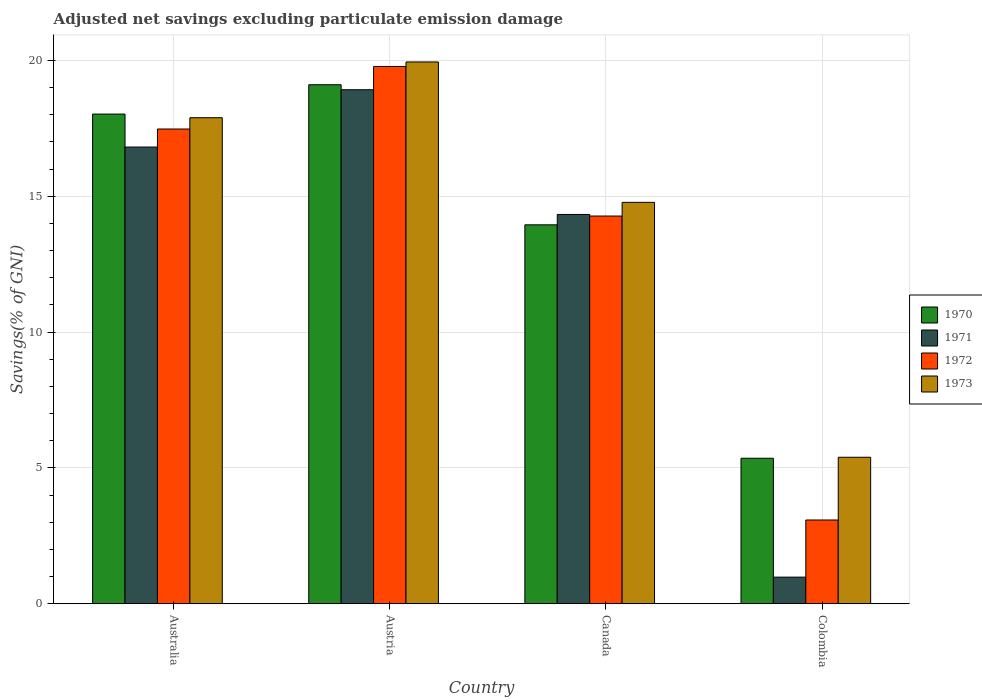How many different coloured bars are there?
Your response must be concise. 4. Are the number of bars on each tick of the X-axis equal?
Your answer should be very brief. Yes. How many bars are there on the 1st tick from the right?
Make the answer very short. 4. What is the label of the 3rd group of bars from the left?
Your answer should be very brief. Canada. What is the adjusted net savings in 1973 in Canada?
Offer a very short reply. 14.78. Across all countries, what is the maximum adjusted net savings in 1973?
Offer a very short reply. 19.94. Across all countries, what is the minimum adjusted net savings in 1971?
Offer a terse response. 0.98. In which country was the adjusted net savings in 1970 minimum?
Offer a terse response. Colombia. What is the total adjusted net savings in 1971 in the graph?
Make the answer very short. 51.04. What is the difference between the adjusted net savings in 1972 in Austria and that in Canada?
Your response must be concise. 5.51. What is the difference between the adjusted net savings in 1971 in Australia and the adjusted net savings in 1973 in Canada?
Your answer should be very brief. 2.04. What is the average adjusted net savings in 1972 per country?
Give a very brief answer. 13.65. What is the difference between the adjusted net savings of/in 1972 and adjusted net savings of/in 1971 in Colombia?
Make the answer very short. 2.1. In how many countries, is the adjusted net savings in 1972 greater than 3 %?
Give a very brief answer. 4. What is the ratio of the adjusted net savings in 1970 in Australia to that in Colombia?
Provide a short and direct response. 3.37. Is the adjusted net savings in 1971 in Austria less than that in Colombia?
Ensure brevity in your answer.  No. What is the difference between the highest and the second highest adjusted net savings in 1972?
Provide a short and direct response. -2.3. What is the difference between the highest and the lowest adjusted net savings in 1971?
Your response must be concise. 17.94. In how many countries, is the adjusted net savings in 1970 greater than the average adjusted net savings in 1970 taken over all countries?
Offer a terse response. 2. What does the 2nd bar from the right in Australia represents?
Make the answer very short. 1972. How many bars are there?
Ensure brevity in your answer.  16. Are all the bars in the graph horizontal?
Offer a very short reply. No. Does the graph contain any zero values?
Keep it short and to the point. No. Does the graph contain grids?
Offer a very short reply. Yes. What is the title of the graph?
Provide a succinct answer. Adjusted net savings excluding particulate emission damage. What is the label or title of the X-axis?
Offer a very short reply. Country. What is the label or title of the Y-axis?
Give a very brief answer. Savings(% of GNI). What is the Savings(% of GNI) of 1970 in Australia?
Offer a very short reply. 18.03. What is the Savings(% of GNI) of 1971 in Australia?
Your answer should be very brief. 16.81. What is the Savings(% of GNI) in 1972 in Australia?
Ensure brevity in your answer.  17.48. What is the Savings(% of GNI) in 1973 in Australia?
Keep it short and to the point. 17.89. What is the Savings(% of GNI) in 1970 in Austria?
Your response must be concise. 19.11. What is the Savings(% of GNI) of 1971 in Austria?
Give a very brief answer. 18.92. What is the Savings(% of GNI) of 1972 in Austria?
Your answer should be very brief. 19.78. What is the Savings(% of GNI) of 1973 in Austria?
Your answer should be compact. 19.94. What is the Savings(% of GNI) of 1970 in Canada?
Ensure brevity in your answer.  13.95. What is the Savings(% of GNI) in 1971 in Canada?
Offer a very short reply. 14.33. What is the Savings(% of GNI) in 1972 in Canada?
Your answer should be very brief. 14.27. What is the Savings(% of GNI) in 1973 in Canada?
Provide a succinct answer. 14.78. What is the Savings(% of GNI) in 1970 in Colombia?
Your response must be concise. 5.36. What is the Savings(% of GNI) of 1971 in Colombia?
Your answer should be compact. 0.98. What is the Savings(% of GNI) of 1972 in Colombia?
Your answer should be very brief. 3.08. What is the Savings(% of GNI) of 1973 in Colombia?
Keep it short and to the point. 5.39. Across all countries, what is the maximum Savings(% of GNI) of 1970?
Give a very brief answer. 19.11. Across all countries, what is the maximum Savings(% of GNI) in 1971?
Your response must be concise. 18.92. Across all countries, what is the maximum Savings(% of GNI) of 1972?
Ensure brevity in your answer.  19.78. Across all countries, what is the maximum Savings(% of GNI) in 1973?
Offer a very short reply. 19.94. Across all countries, what is the minimum Savings(% of GNI) in 1970?
Your response must be concise. 5.36. Across all countries, what is the minimum Savings(% of GNI) of 1971?
Provide a succinct answer. 0.98. Across all countries, what is the minimum Savings(% of GNI) in 1972?
Your answer should be compact. 3.08. Across all countries, what is the minimum Savings(% of GNI) in 1973?
Your answer should be very brief. 5.39. What is the total Savings(% of GNI) in 1970 in the graph?
Offer a terse response. 56.44. What is the total Savings(% of GNI) in 1971 in the graph?
Offer a very short reply. 51.04. What is the total Savings(% of GNI) in 1972 in the graph?
Offer a very short reply. 54.61. What is the total Savings(% of GNI) in 1973 in the graph?
Your answer should be very brief. 58.01. What is the difference between the Savings(% of GNI) of 1970 in Australia and that in Austria?
Ensure brevity in your answer.  -1.08. What is the difference between the Savings(% of GNI) in 1971 in Australia and that in Austria?
Your response must be concise. -2.11. What is the difference between the Savings(% of GNI) of 1972 in Australia and that in Austria?
Your response must be concise. -2.3. What is the difference between the Savings(% of GNI) of 1973 in Australia and that in Austria?
Provide a succinct answer. -2.05. What is the difference between the Savings(% of GNI) of 1970 in Australia and that in Canada?
Your response must be concise. 4.08. What is the difference between the Savings(% of GNI) of 1971 in Australia and that in Canada?
Keep it short and to the point. 2.48. What is the difference between the Savings(% of GNI) of 1972 in Australia and that in Canada?
Keep it short and to the point. 3.2. What is the difference between the Savings(% of GNI) of 1973 in Australia and that in Canada?
Keep it short and to the point. 3.12. What is the difference between the Savings(% of GNI) of 1970 in Australia and that in Colombia?
Your answer should be very brief. 12.67. What is the difference between the Savings(% of GNI) in 1971 in Australia and that in Colombia?
Make the answer very short. 15.83. What is the difference between the Savings(% of GNI) in 1972 in Australia and that in Colombia?
Keep it short and to the point. 14.39. What is the difference between the Savings(% of GNI) of 1970 in Austria and that in Canada?
Your response must be concise. 5.16. What is the difference between the Savings(% of GNI) in 1971 in Austria and that in Canada?
Provide a succinct answer. 4.59. What is the difference between the Savings(% of GNI) in 1972 in Austria and that in Canada?
Offer a very short reply. 5.51. What is the difference between the Savings(% of GNI) of 1973 in Austria and that in Canada?
Provide a short and direct response. 5.17. What is the difference between the Savings(% of GNI) of 1970 in Austria and that in Colombia?
Provide a short and direct response. 13.75. What is the difference between the Savings(% of GNI) in 1971 in Austria and that in Colombia?
Provide a succinct answer. 17.94. What is the difference between the Savings(% of GNI) in 1972 in Austria and that in Colombia?
Give a very brief answer. 16.7. What is the difference between the Savings(% of GNI) in 1973 in Austria and that in Colombia?
Provide a succinct answer. 14.55. What is the difference between the Savings(% of GNI) of 1970 in Canada and that in Colombia?
Your response must be concise. 8.59. What is the difference between the Savings(% of GNI) of 1971 in Canada and that in Colombia?
Ensure brevity in your answer.  13.35. What is the difference between the Savings(% of GNI) in 1972 in Canada and that in Colombia?
Offer a very short reply. 11.19. What is the difference between the Savings(% of GNI) in 1973 in Canada and that in Colombia?
Your answer should be compact. 9.38. What is the difference between the Savings(% of GNI) in 1970 in Australia and the Savings(% of GNI) in 1971 in Austria?
Your answer should be compact. -0.9. What is the difference between the Savings(% of GNI) in 1970 in Australia and the Savings(% of GNI) in 1972 in Austria?
Your answer should be very brief. -1.75. What is the difference between the Savings(% of GNI) of 1970 in Australia and the Savings(% of GNI) of 1973 in Austria?
Offer a terse response. -1.92. What is the difference between the Savings(% of GNI) in 1971 in Australia and the Savings(% of GNI) in 1972 in Austria?
Your response must be concise. -2.97. What is the difference between the Savings(% of GNI) of 1971 in Australia and the Savings(% of GNI) of 1973 in Austria?
Your answer should be very brief. -3.13. What is the difference between the Savings(% of GNI) in 1972 in Australia and the Savings(% of GNI) in 1973 in Austria?
Ensure brevity in your answer.  -2.47. What is the difference between the Savings(% of GNI) in 1970 in Australia and the Savings(% of GNI) in 1971 in Canada?
Your response must be concise. 3.7. What is the difference between the Savings(% of GNI) in 1970 in Australia and the Savings(% of GNI) in 1972 in Canada?
Keep it short and to the point. 3.75. What is the difference between the Savings(% of GNI) of 1970 in Australia and the Savings(% of GNI) of 1973 in Canada?
Offer a very short reply. 3.25. What is the difference between the Savings(% of GNI) of 1971 in Australia and the Savings(% of GNI) of 1972 in Canada?
Offer a terse response. 2.54. What is the difference between the Savings(% of GNI) of 1971 in Australia and the Savings(% of GNI) of 1973 in Canada?
Offer a terse response. 2.04. What is the difference between the Savings(% of GNI) in 1972 in Australia and the Savings(% of GNI) in 1973 in Canada?
Ensure brevity in your answer.  2.7. What is the difference between the Savings(% of GNI) in 1970 in Australia and the Savings(% of GNI) in 1971 in Colombia?
Make the answer very short. 17.05. What is the difference between the Savings(% of GNI) of 1970 in Australia and the Savings(% of GNI) of 1972 in Colombia?
Your answer should be very brief. 14.94. What is the difference between the Savings(% of GNI) in 1970 in Australia and the Savings(% of GNI) in 1973 in Colombia?
Give a very brief answer. 12.63. What is the difference between the Savings(% of GNI) in 1971 in Australia and the Savings(% of GNI) in 1972 in Colombia?
Your response must be concise. 13.73. What is the difference between the Savings(% of GNI) of 1971 in Australia and the Savings(% of GNI) of 1973 in Colombia?
Provide a succinct answer. 11.42. What is the difference between the Savings(% of GNI) in 1972 in Australia and the Savings(% of GNI) in 1973 in Colombia?
Give a very brief answer. 12.08. What is the difference between the Savings(% of GNI) in 1970 in Austria and the Savings(% of GNI) in 1971 in Canada?
Offer a terse response. 4.77. What is the difference between the Savings(% of GNI) of 1970 in Austria and the Savings(% of GNI) of 1972 in Canada?
Give a very brief answer. 4.83. What is the difference between the Savings(% of GNI) of 1970 in Austria and the Savings(% of GNI) of 1973 in Canada?
Your answer should be very brief. 4.33. What is the difference between the Savings(% of GNI) of 1971 in Austria and the Savings(% of GNI) of 1972 in Canada?
Your answer should be very brief. 4.65. What is the difference between the Savings(% of GNI) in 1971 in Austria and the Savings(% of GNI) in 1973 in Canada?
Make the answer very short. 4.15. What is the difference between the Savings(% of GNI) of 1972 in Austria and the Savings(% of GNI) of 1973 in Canada?
Provide a succinct answer. 5. What is the difference between the Savings(% of GNI) in 1970 in Austria and the Savings(% of GNI) in 1971 in Colombia?
Offer a terse response. 18.13. What is the difference between the Savings(% of GNI) in 1970 in Austria and the Savings(% of GNI) in 1972 in Colombia?
Offer a very short reply. 16.02. What is the difference between the Savings(% of GNI) of 1970 in Austria and the Savings(% of GNI) of 1973 in Colombia?
Your response must be concise. 13.71. What is the difference between the Savings(% of GNI) in 1971 in Austria and the Savings(% of GNI) in 1972 in Colombia?
Provide a succinct answer. 15.84. What is the difference between the Savings(% of GNI) of 1971 in Austria and the Savings(% of GNI) of 1973 in Colombia?
Offer a very short reply. 13.53. What is the difference between the Savings(% of GNI) of 1972 in Austria and the Savings(% of GNI) of 1973 in Colombia?
Provide a short and direct response. 14.39. What is the difference between the Savings(% of GNI) of 1970 in Canada and the Savings(% of GNI) of 1971 in Colombia?
Ensure brevity in your answer.  12.97. What is the difference between the Savings(% of GNI) in 1970 in Canada and the Savings(% of GNI) in 1972 in Colombia?
Make the answer very short. 10.87. What is the difference between the Savings(% of GNI) of 1970 in Canada and the Savings(% of GNI) of 1973 in Colombia?
Give a very brief answer. 8.56. What is the difference between the Savings(% of GNI) in 1971 in Canada and the Savings(% of GNI) in 1972 in Colombia?
Keep it short and to the point. 11.25. What is the difference between the Savings(% of GNI) in 1971 in Canada and the Savings(% of GNI) in 1973 in Colombia?
Your response must be concise. 8.94. What is the difference between the Savings(% of GNI) of 1972 in Canada and the Savings(% of GNI) of 1973 in Colombia?
Provide a short and direct response. 8.88. What is the average Savings(% of GNI) of 1970 per country?
Keep it short and to the point. 14.11. What is the average Savings(% of GNI) of 1971 per country?
Provide a short and direct response. 12.76. What is the average Savings(% of GNI) of 1972 per country?
Ensure brevity in your answer.  13.65. What is the average Savings(% of GNI) of 1973 per country?
Provide a short and direct response. 14.5. What is the difference between the Savings(% of GNI) of 1970 and Savings(% of GNI) of 1971 in Australia?
Offer a very short reply. 1.21. What is the difference between the Savings(% of GNI) in 1970 and Savings(% of GNI) in 1972 in Australia?
Provide a succinct answer. 0.55. What is the difference between the Savings(% of GNI) of 1970 and Savings(% of GNI) of 1973 in Australia?
Keep it short and to the point. 0.13. What is the difference between the Savings(% of GNI) in 1971 and Savings(% of GNI) in 1972 in Australia?
Keep it short and to the point. -0.66. What is the difference between the Savings(% of GNI) of 1971 and Savings(% of GNI) of 1973 in Australia?
Your answer should be compact. -1.08. What is the difference between the Savings(% of GNI) of 1972 and Savings(% of GNI) of 1973 in Australia?
Provide a short and direct response. -0.42. What is the difference between the Savings(% of GNI) in 1970 and Savings(% of GNI) in 1971 in Austria?
Provide a short and direct response. 0.18. What is the difference between the Savings(% of GNI) in 1970 and Savings(% of GNI) in 1972 in Austria?
Make the answer very short. -0.67. What is the difference between the Savings(% of GNI) of 1970 and Savings(% of GNI) of 1973 in Austria?
Offer a very short reply. -0.84. What is the difference between the Savings(% of GNI) of 1971 and Savings(% of GNI) of 1972 in Austria?
Give a very brief answer. -0.86. What is the difference between the Savings(% of GNI) of 1971 and Savings(% of GNI) of 1973 in Austria?
Your response must be concise. -1.02. What is the difference between the Savings(% of GNI) of 1972 and Savings(% of GNI) of 1973 in Austria?
Make the answer very short. -0.17. What is the difference between the Savings(% of GNI) in 1970 and Savings(% of GNI) in 1971 in Canada?
Your answer should be very brief. -0.38. What is the difference between the Savings(% of GNI) of 1970 and Savings(% of GNI) of 1972 in Canada?
Make the answer very short. -0.32. What is the difference between the Savings(% of GNI) of 1970 and Savings(% of GNI) of 1973 in Canada?
Your response must be concise. -0.83. What is the difference between the Savings(% of GNI) of 1971 and Savings(% of GNI) of 1972 in Canada?
Provide a short and direct response. 0.06. What is the difference between the Savings(% of GNI) in 1971 and Savings(% of GNI) in 1973 in Canada?
Offer a very short reply. -0.45. What is the difference between the Savings(% of GNI) of 1972 and Savings(% of GNI) of 1973 in Canada?
Your answer should be very brief. -0.5. What is the difference between the Savings(% of GNI) in 1970 and Savings(% of GNI) in 1971 in Colombia?
Offer a very short reply. 4.38. What is the difference between the Savings(% of GNI) of 1970 and Savings(% of GNI) of 1972 in Colombia?
Give a very brief answer. 2.27. What is the difference between the Savings(% of GNI) of 1970 and Savings(% of GNI) of 1973 in Colombia?
Offer a very short reply. -0.04. What is the difference between the Savings(% of GNI) of 1971 and Savings(% of GNI) of 1972 in Colombia?
Provide a short and direct response. -2.1. What is the difference between the Savings(% of GNI) of 1971 and Savings(% of GNI) of 1973 in Colombia?
Give a very brief answer. -4.41. What is the difference between the Savings(% of GNI) of 1972 and Savings(% of GNI) of 1973 in Colombia?
Keep it short and to the point. -2.31. What is the ratio of the Savings(% of GNI) in 1970 in Australia to that in Austria?
Your response must be concise. 0.94. What is the ratio of the Savings(% of GNI) in 1971 in Australia to that in Austria?
Provide a short and direct response. 0.89. What is the ratio of the Savings(% of GNI) in 1972 in Australia to that in Austria?
Ensure brevity in your answer.  0.88. What is the ratio of the Savings(% of GNI) in 1973 in Australia to that in Austria?
Keep it short and to the point. 0.9. What is the ratio of the Savings(% of GNI) of 1970 in Australia to that in Canada?
Your answer should be compact. 1.29. What is the ratio of the Savings(% of GNI) of 1971 in Australia to that in Canada?
Ensure brevity in your answer.  1.17. What is the ratio of the Savings(% of GNI) of 1972 in Australia to that in Canada?
Keep it short and to the point. 1.22. What is the ratio of the Savings(% of GNI) of 1973 in Australia to that in Canada?
Keep it short and to the point. 1.21. What is the ratio of the Savings(% of GNI) of 1970 in Australia to that in Colombia?
Your answer should be very brief. 3.37. What is the ratio of the Savings(% of GNI) of 1971 in Australia to that in Colombia?
Keep it short and to the point. 17.17. What is the ratio of the Savings(% of GNI) in 1972 in Australia to that in Colombia?
Provide a short and direct response. 5.67. What is the ratio of the Savings(% of GNI) in 1973 in Australia to that in Colombia?
Your response must be concise. 3.32. What is the ratio of the Savings(% of GNI) in 1970 in Austria to that in Canada?
Offer a terse response. 1.37. What is the ratio of the Savings(% of GNI) in 1971 in Austria to that in Canada?
Give a very brief answer. 1.32. What is the ratio of the Savings(% of GNI) in 1972 in Austria to that in Canada?
Your answer should be very brief. 1.39. What is the ratio of the Savings(% of GNI) of 1973 in Austria to that in Canada?
Provide a short and direct response. 1.35. What is the ratio of the Savings(% of GNI) of 1970 in Austria to that in Colombia?
Provide a short and direct response. 3.57. What is the ratio of the Savings(% of GNI) of 1971 in Austria to that in Colombia?
Offer a very short reply. 19.32. What is the ratio of the Savings(% of GNI) of 1972 in Austria to that in Colombia?
Your answer should be compact. 6.42. What is the ratio of the Savings(% of GNI) in 1973 in Austria to that in Colombia?
Provide a short and direct response. 3.7. What is the ratio of the Savings(% of GNI) of 1970 in Canada to that in Colombia?
Offer a very short reply. 2.6. What is the ratio of the Savings(% of GNI) of 1971 in Canada to that in Colombia?
Your answer should be compact. 14.64. What is the ratio of the Savings(% of GNI) in 1972 in Canada to that in Colombia?
Your answer should be very brief. 4.63. What is the ratio of the Savings(% of GNI) in 1973 in Canada to that in Colombia?
Your answer should be very brief. 2.74. What is the difference between the highest and the second highest Savings(% of GNI) in 1970?
Ensure brevity in your answer.  1.08. What is the difference between the highest and the second highest Savings(% of GNI) in 1971?
Ensure brevity in your answer.  2.11. What is the difference between the highest and the second highest Savings(% of GNI) in 1972?
Make the answer very short. 2.3. What is the difference between the highest and the second highest Savings(% of GNI) in 1973?
Offer a very short reply. 2.05. What is the difference between the highest and the lowest Savings(% of GNI) of 1970?
Offer a terse response. 13.75. What is the difference between the highest and the lowest Savings(% of GNI) of 1971?
Give a very brief answer. 17.94. What is the difference between the highest and the lowest Savings(% of GNI) in 1972?
Your answer should be very brief. 16.7. What is the difference between the highest and the lowest Savings(% of GNI) in 1973?
Ensure brevity in your answer.  14.55. 